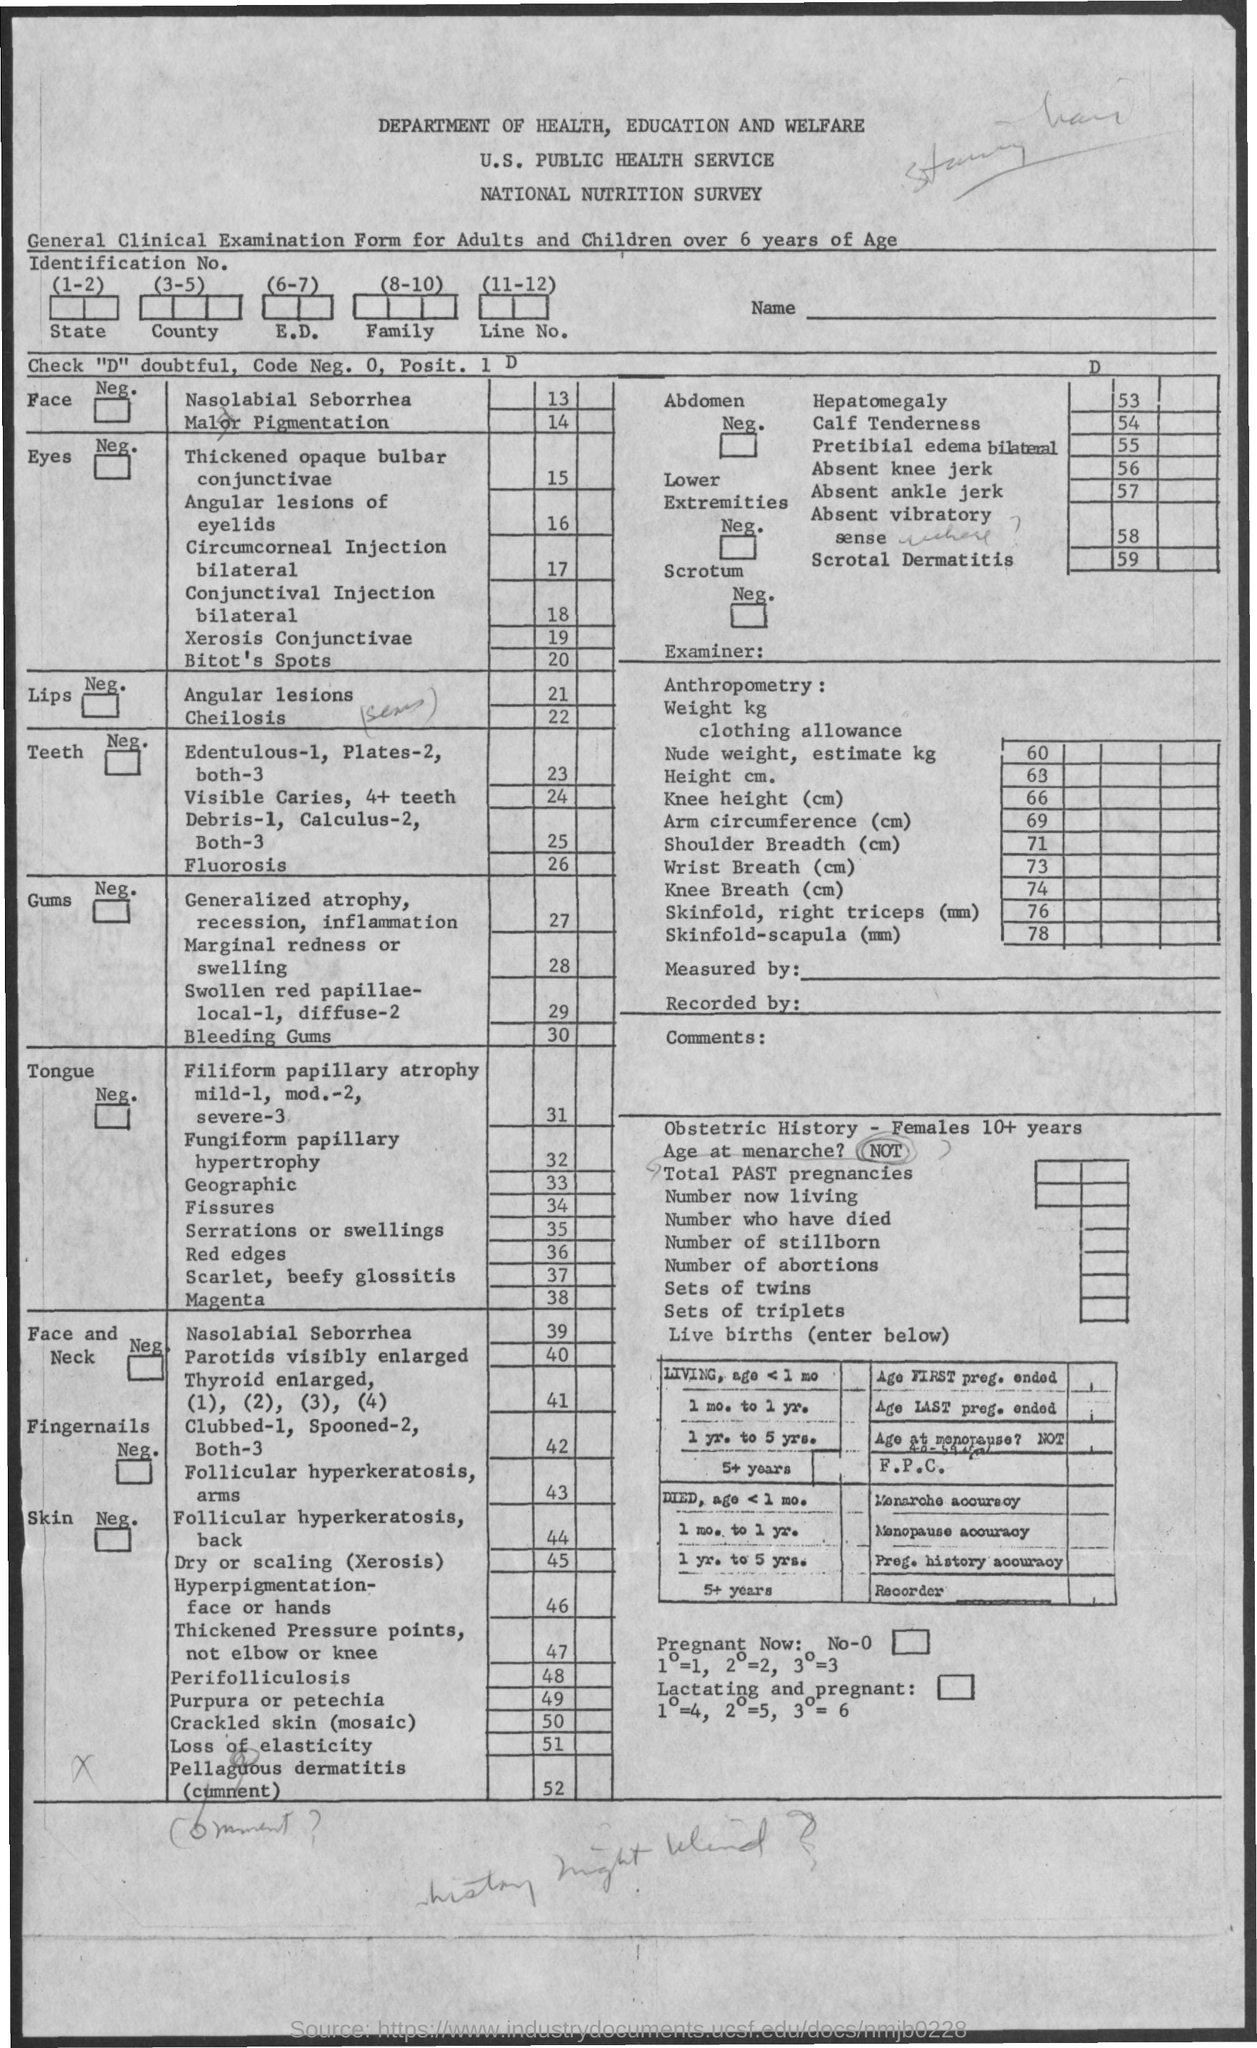Draw attention to some important aspects in this diagram. The name of the survey is the National Nutrition Survey. The Department of Health, Education, and Welfare is mentioned. 